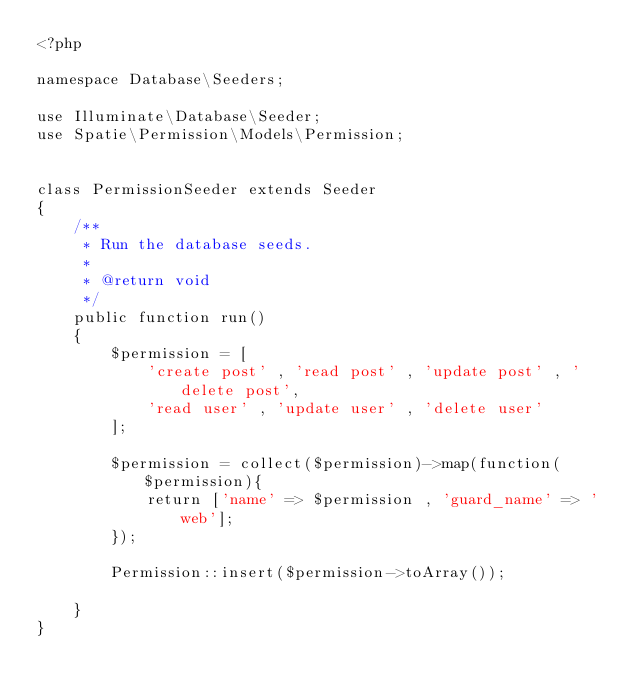Convert code to text. <code><loc_0><loc_0><loc_500><loc_500><_PHP_><?php

namespace Database\Seeders;

use Illuminate\Database\Seeder;
use Spatie\Permission\Models\Permission;


class PermissionSeeder extends Seeder
{
    /**
     * Run the database seeds.
     *
     * @return void
     */
    public function run()
    {
        $permission = [
            'create post' , 'read post' , 'update post' , 'delete post',
            'read user' , 'update user' , 'delete user'
        ];

        $permission = collect($permission)->map(function($permission){
            return ['name' => $permission , 'guard_name' => 'web'];
        });

        Permission::insert($permission->toArray());

    }
}
</code> 